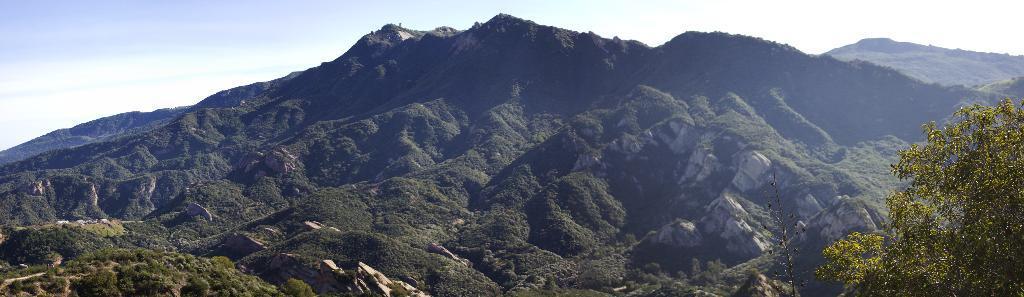Describe this image in one or two sentences. On the right side of the image we can see there is a tree. In the center of the image there are mountains and sky. 